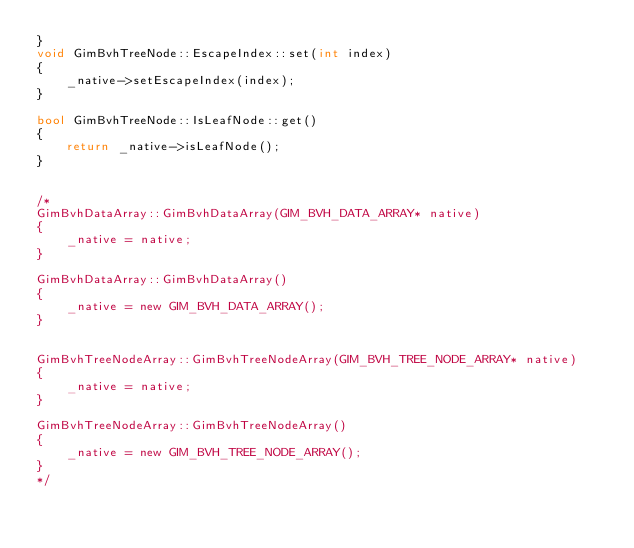<code> <loc_0><loc_0><loc_500><loc_500><_C++_>}
void GimBvhTreeNode::EscapeIndex::set(int index)
{
	_native->setEscapeIndex(index);
}

bool GimBvhTreeNode::IsLeafNode::get()
{
	return _native->isLeafNode();
}


/*
GimBvhDataArray::GimBvhDataArray(GIM_BVH_DATA_ARRAY* native)
{
	_native = native;
}

GimBvhDataArray::GimBvhDataArray()
{
	_native = new GIM_BVH_DATA_ARRAY();
}


GimBvhTreeNodeArray::GimBvhTreeNodeArray(GIM_BVH_TREE_NODE_ARRAY* native)
{
	_native = native;
}

GimBvhTreeNodeArray::GimBvhTreeNodeArray()
{
	_native = new GIM_BVH_TREE_NODE_ARRAY();
}
*/

</code> 